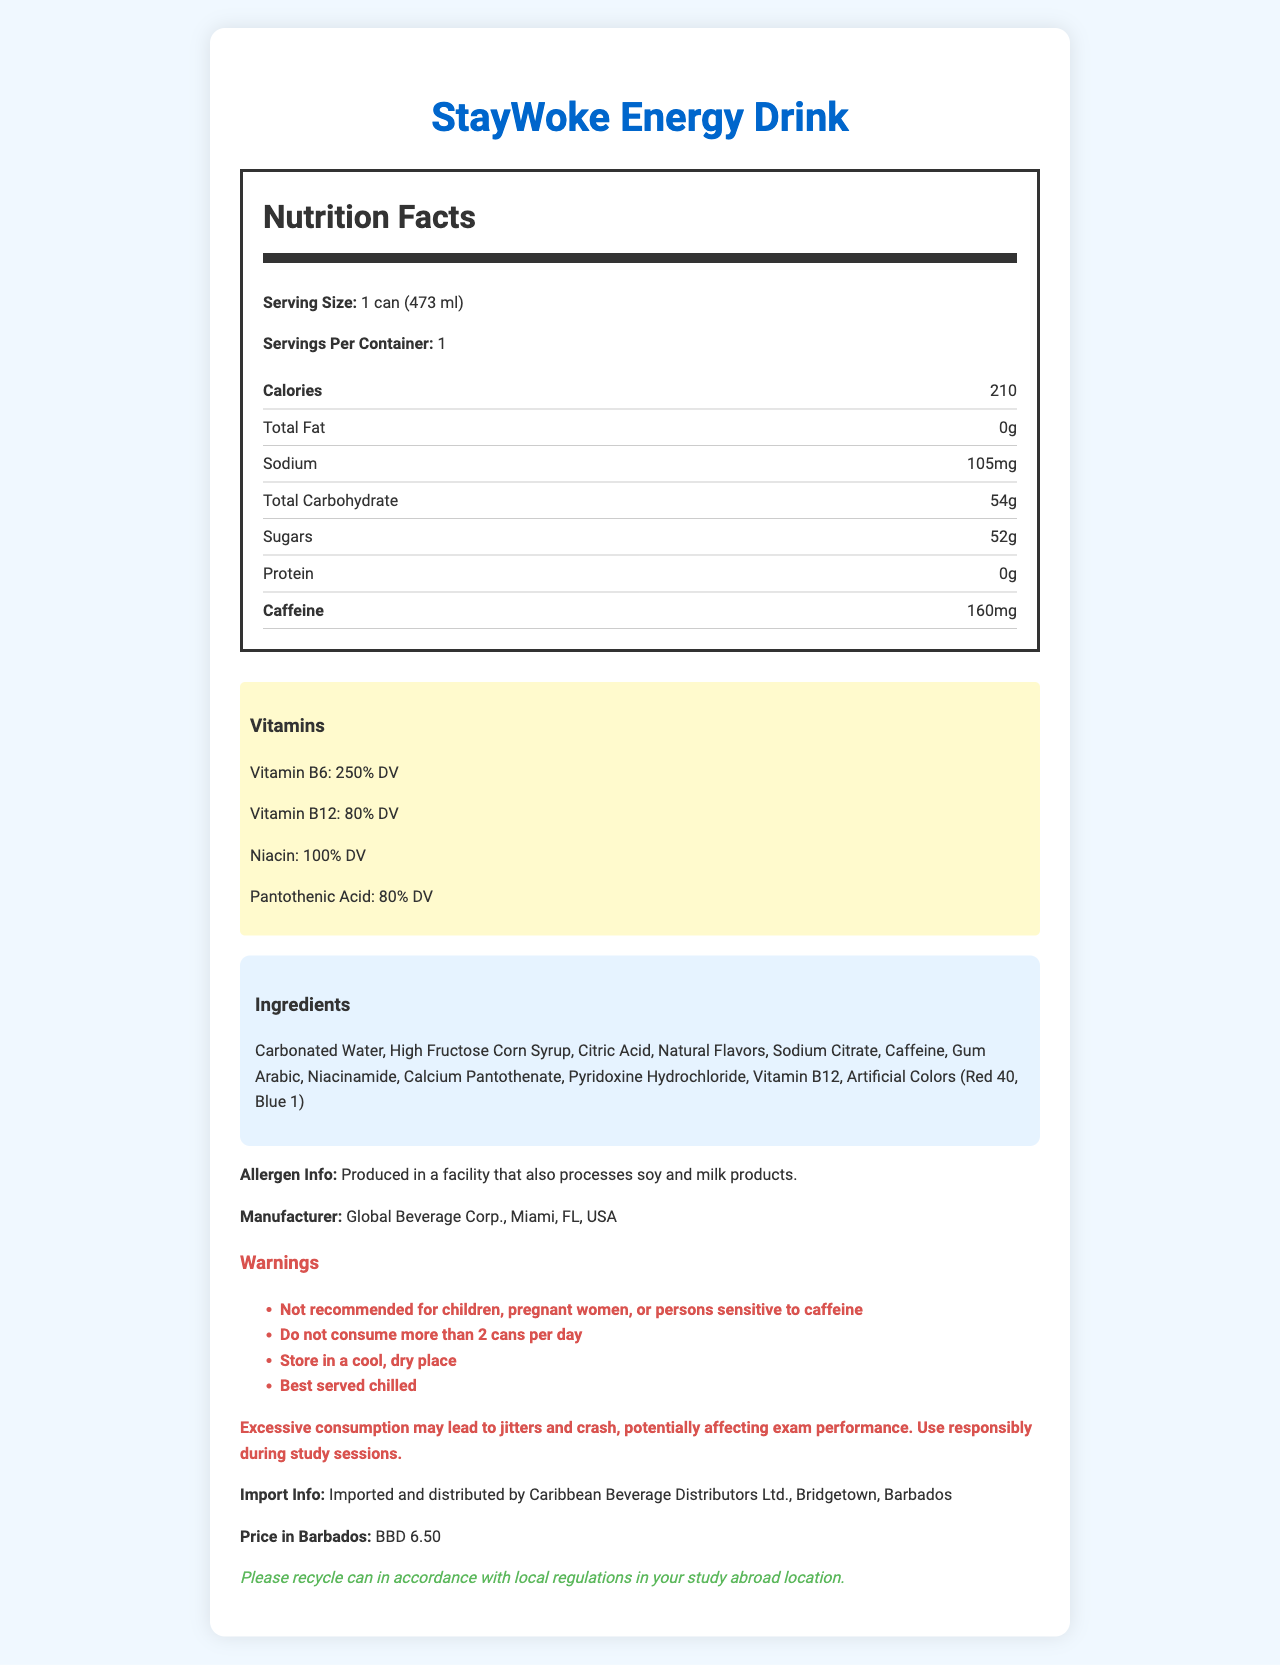what is the serving size? The serving size is explicitly stated as "1 can (473 ml)" in the Nutrition Facts section.
Answer: 1 can (473 ml) how many calories are in one serving of StayWoke Energy Drink? The number of calories per serving is listed as 210 in the Nutrition Facts section.
Answer: 210 how much caffeine is in one can of StayWoke Energy Drink? The amount of caffeine is noted as 160mg in the Nutrition Facts section.
Answer: 160mg what is the total carbohydrate content per serving? The total carbohydrate content per serving is 54g as stated in the Nutrition Facts section.
Answer: 54g how much sugar is present in one can of StayWoke Energy Drink? The amount of sugar per serving is listed as 52g in the Nutrition Facts section.
Answer: 52g which vitamins are present in the StayWoke Energy Drink? A. Vitamin C, Vitamin D B. Vitamin B6, Vitamin B12, Niacin, Pantothenic Acid C. Vitamin A, Vitamin E The document highlights Vitamin B6, Vitamin B12, Niacin, and Pantothenic Acid as the vitamins present in the drink.
Answer: B what is the role of calcium pantothenate listed in the ingredients? A. It’s a type of preservative B. It provides Vitamin B5 C. It adds flavor Calcium pantothenate is listed among the ingredients and known for providing Vitamin B5 (Pantothenic Acid).
Answer: B is this product recommended for children? The document includes an additional info section that states, "Not recommended for children, pregnant women, or persons sensitive to caffeine."
Answer: No which company manufactures StayWoke Energy Drink? The manufacturer's information is clearly stated as "Global Beverage Corp., Miami, FL, USA."
Answer: Global Beverage Corp., Miami, FL, USA what is the price of StayWoke Energy Drink in Barbados? The price in Barbados is indicated as BBD 6.50.
Answer: BBD 6.50 where is the StayWoke Energy Drink imported and distributed in Barbados? Import and distribution details show "Caribbean Beverage Distributors Ltd., Bridgetown, Barbados."
Answer: Caribbean Beverage Distributors Ltd., Bridgetown, Barbados what are some potential side effects of consuming too much StayWoke Energy Drink? A warning section specifically mentions that "Excessive consumption may lead to jitters and crash, potentially affecting exam performance."
Answer: Jitters and crash, potentially affecting exam performance how does the StayWoke Energy Drink address eco-friendliness? The eco-friendly note mentions "Please recycle can in accordance with local regulations in your study abroad location."
Answer: Please recycle can in accordance with local regulations provide a summary of the Nutrition Facts for StayWoke Energy Drink This summary captures the key nutritional information, ingredients, vitamin content, and warnings presented in the document.
Answer: "The Nutrition Facts label for StayWoke Energy Drink lists a serving size of 1 can (473 ml), containing 210 calories. It has 0g of total fat, 105mg of sodium, 54g of total carbohydrates out of which 52g are sugars, and 0g of protein. The caffeine content is 160mg. It also contains high percentages of Vitamin B6, Vitamin B12, Niacin, and Pantothenic Acid. The ingredients include carbonated water, high fructose corn syrup, citric acid, natural flavors, and more. Warnings are given about excessive consumption and its side effects, especially for students." what is the production location of StayWoke Energy Drink? The document provides the location of the manufacturer (Global Beverage Corp., Miami, FL, USA) but does not specify the exact production location.
Answer: Cannot be determined 